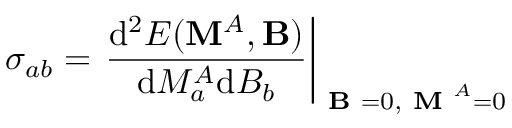Convert formula to latex. <formula><loc_0><loc_0><loc_500><loc_500>\sigma _ { a b } = \frac { d ^ { 2 } E ( M ^ { A } , B ) } { d M _ { a } ^ { A } d B _ { b } } \right | _ { B = 0 , M ^ { A } = 0 }</formula> 